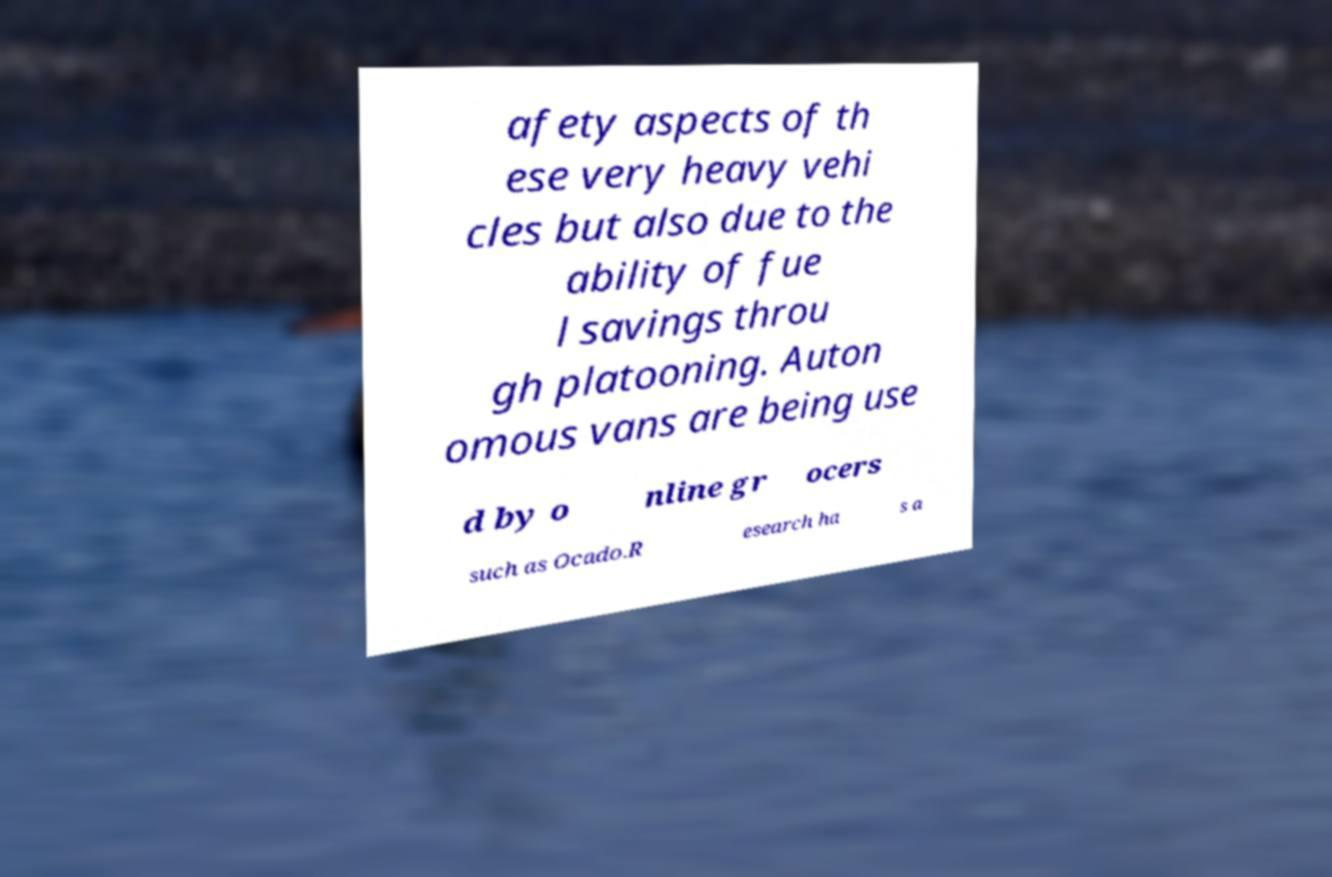Can you read and provide the text displayed in the image?This photo seems to have some interesting text. Can you extract and type it out for me? afety aspects of th ese very heavy vehi cles but also due to the ability of fue l savings throu gh platooning. Auton omous vans are being use d by o nline gr ocers such as Ocado.R esearch ha s a 